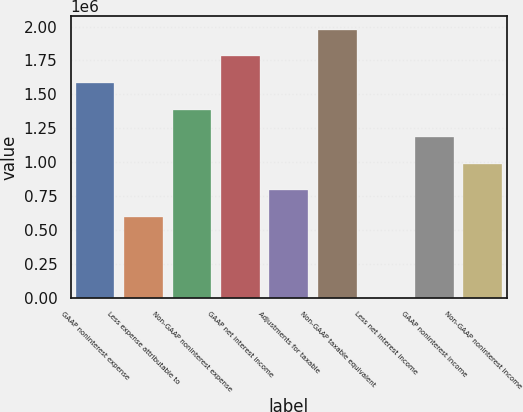Convert chart to OTSL. <chart><loc_0><loc_0><loc_500><loc_500><bar_chart><fcel>GAAP noninterest expense<fcel>Less expense attributable to<fcel>Non-GAAP noninterest expense<fcel>GAAP net interest income<fcel>Adjustments for taxable<fcel>Non-GAAP taxable equivalent<fcel>Less net interest income<fcel>GAAP noninterest income<fcel>Non-GAAP noninterest income<nl><fcel>1.58209e+06<fcel>593303<fcel>1.38433e+06<fcel>1.77984e+06<fcel>791060<fcel>1.9776e+06<fcel>33<fcel>1.18657e+06<fcel>988816<nl></chart> 